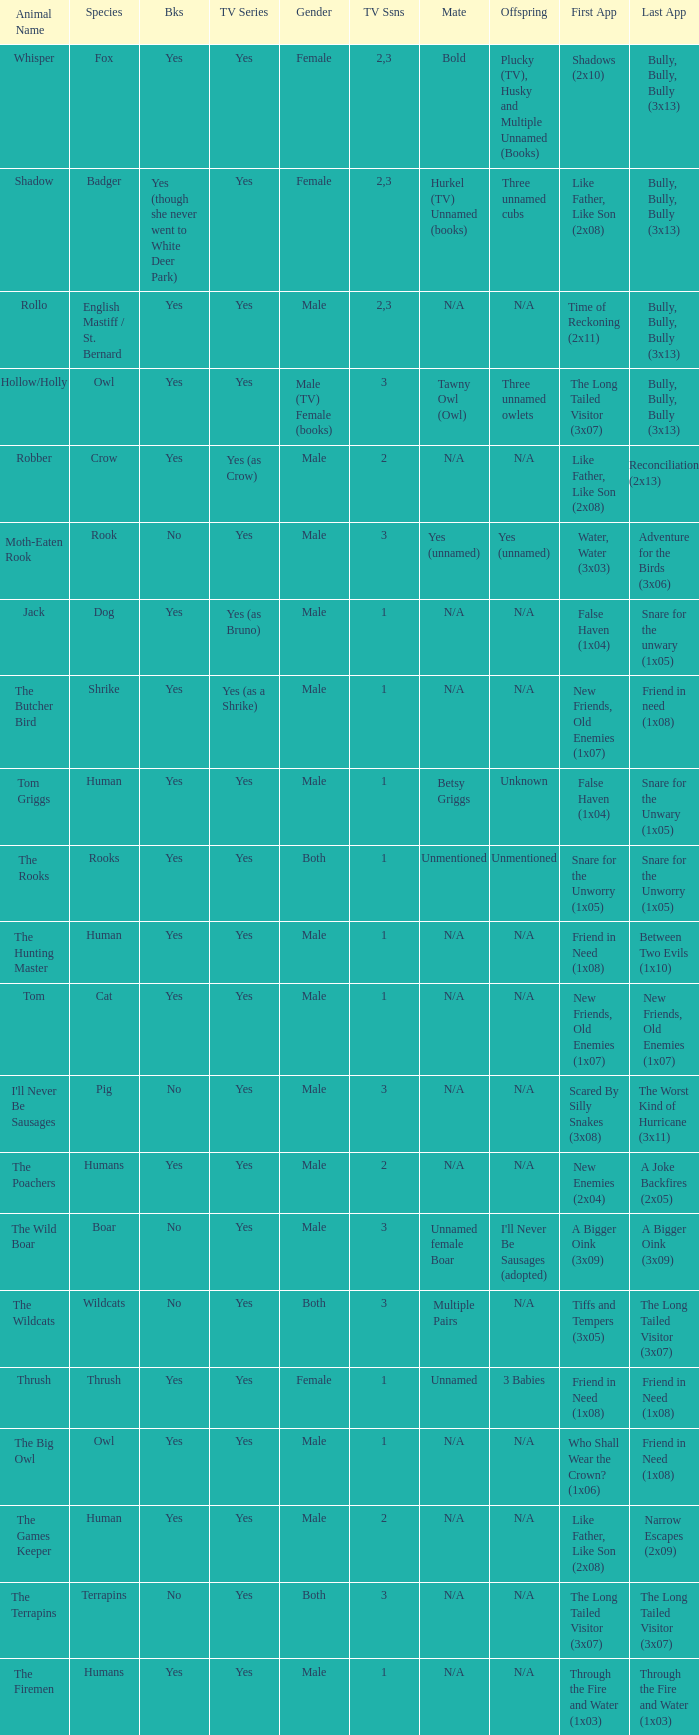What animal was yes for tv series and was a terrapins? The Terrapins. 